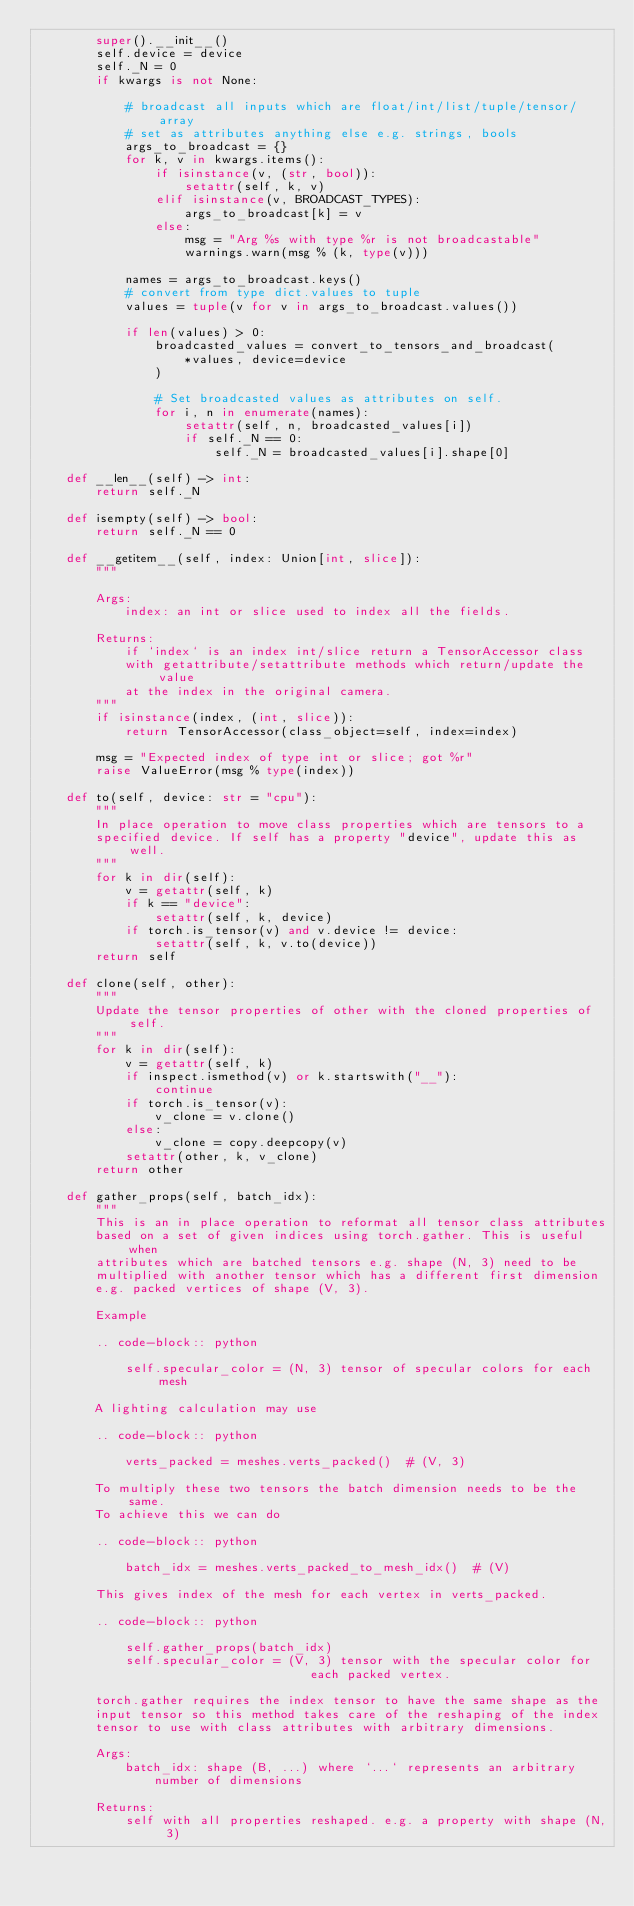<code> <loc_0><loc_0><loc_500><loc_500><_Python_>        super().__init__()
        self.device = device
        self._N = 0
        if kwargs is not None:

            # broadcast all inputs which are float/int/list/tuple/tensor/array
            # set as attributes anything else e.g. strings, bools
            args_to_broadcast = {}
            for k, v in kwargs.items():
                if isinstance(v, (str, bool)):
                    setattr(self, k, v)
                elif isinstance(v, BROADCAST_TYPES):
                    args_to_broadcast[k] = v
                else:
                    msg = "Arg %s with type %r is not broadcastable"
                    warnings.warn(msg % (k, type(v)))

            names = args_to_broadcast.keys()
            # convert from type dict.values to tuple
            values = tuple(v for v in args_to_broadcast.values())

            if len(values) > 0:
                broadcasted_values = convert_to_tensors_and_broadcast(
                    *values, device=device
                )

                # Set broadcasted values as attributes on self.
                for i, n in enumerate(names):
                    setattr(self, n, broadcasted_values[i])
                    if self._N == 0:
                        self._N = broadcasted_values[i].shape[0]

    def __len__(self) -> int:
        return self._N

    def isempty(self) -> bool:
        return self._N == 0

    def __getitem__(self, index: Union[int, slice]):
        """

        Args:
            index: an int or slice used to index all the fields.

        Returns:
            if `index` is an index int/slice return a TensorAccessor class
            with getattribute/setattribute methods which return/update the value
            at the index in the original camera.
        """
        if isinstance(index, (int, slice)):
            return TensorAccessor(class_object=self, index=index)

        msg = "Expected index of type int or slice; got %r"
        raise ValueError(msg % type(index))

    def to(self, device: str = "cpu"):
        """
        In place operation to move class properties which are tensors to a
        specified device. If self has a property "device", update this as well.
        """
        for k in dir(self):
            v = getattr(self, k)
            if k == "device":
                setattr(self, k, device)
            if torch.is_tensor(v) and v.device != device:
                setattr(self, k, v.to(device))
        return self

    def clone(self, other):
        """
        Update the tensor properties of other with the cloned properties of self.
        """
        for k in dir(self):
            v = getattr(self, k)
            if inspect.ismethod(v) or k.startswith("__"):
                continue
            if torch.is_tensor(v):
                v_clone = v.clone()
            else:
                v_clone = copy.deepcopy(v)
            setattr(other, k, v_clone)
        return other

    def gather_props(self, batch_idx):
        """
        This is an in place operation to reformat all tensor class attributes
        based on a set of given indices using torch.gather. This is useful when
        attributes which are batched tensors e.g. shape (N, 3) need to be
        multiplied with another tensor which has a different first dimension
        e.g. packed vertices of shape (V, 3).

        Example

        .. code-block:: python

            self.specular_color = (N, 3) tensor of specular colors for each mesh

        A lighting calculation may use

        .. code-block:: python

            verts_packed = meshes.verts_packed()  # (V, 3)

        To multiply these two tensors the batch dimension needs to be the same.
        To achieve this we can do

        .. code-block:: python

            batch_idx = meshes.verts_packed_to_mesh_idx()  # (V)

        This gives index of the mesh for each vertex in verts_packed.

        .. code-block:: python

            self.gather_props(batch_idx)
            self.specular_color = (V, 3) tensor with the specular color for
                                     each packed vertex.

        torch.gather requires the index tensor to have the same shape as the
        input tensor so this method takes care of the reshaping of the index
        tensor to use with class attributes with arbitrary dimensions.

        Args:
            batch_idx: shape (B, ...) where `...` represents an arbitrary
                number of dimensions

        Returns:
            self with all properties reshaped. e.g. a property with shape (N, 3)</code> 